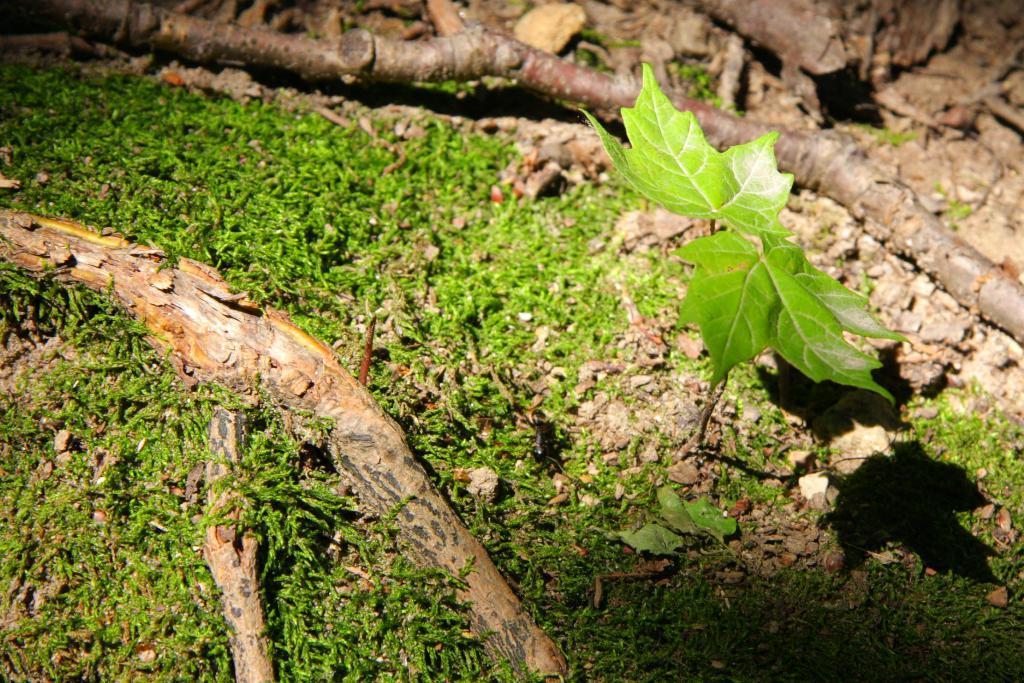Please provide a concise description of this image. In this image, we can see the ground with some grass, a plant and some wooden objects. 